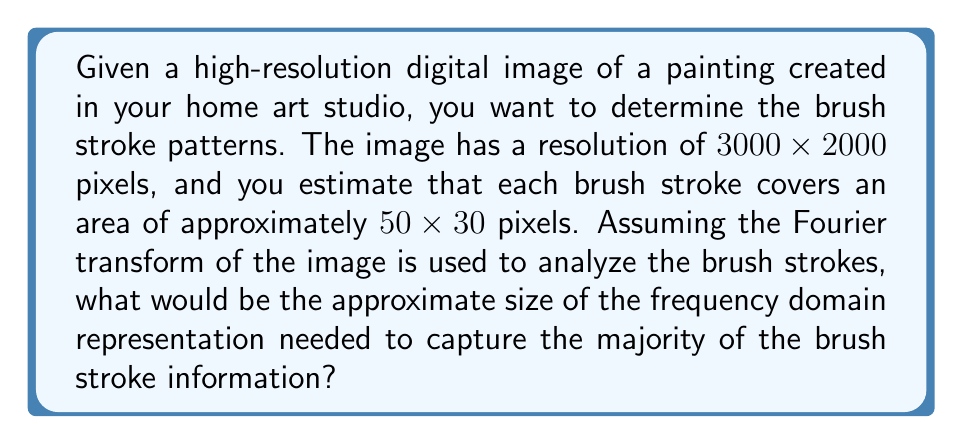Teach me how to tackle this problem. To solve this problem, we'll follow these steps:

1. Determine the spatial frequency of the brush strokes:
   The brush stroke size is 50x30 pixels.
   Spatial frequency in x-direction: $f_x = \frac{1}{50}$ cycles/pixel
   Spatial frequency in y-direction: $f_y = \frac{1}{30}$ cycles/pixel

2. Calculate the Nyquist frequency:
   Nyquist frequency is twice the highest frequency component.
   $f_{Nyquist,x} = 2 \cdot \frac{1}{50} = \frac{1}{25}$ cycles/pixel
   $f_{Nyquist,y} = 2 \cdot \frac{1}{30} = \frac{1}{15}$ cycles/pixel

3. Determine the required frequency domain size:
   For x-direction: $\frac{3000}{25} = 120$ frequency components
   For y-direction: $\frac{2000}{15} \approx 133$ frequency components

4. The frequency domain representation should be at least 120x133 to capture the majority of the brush stroke information.

5. To ensure we capture all relevant information and account for some margin, we can round up to the nearest power of 2, which is 128x256.

Therefore, the approximate size of the frequency domain representation needed to capture the majority of the brush stroke information would be 128x256.
Answer: 128x256 